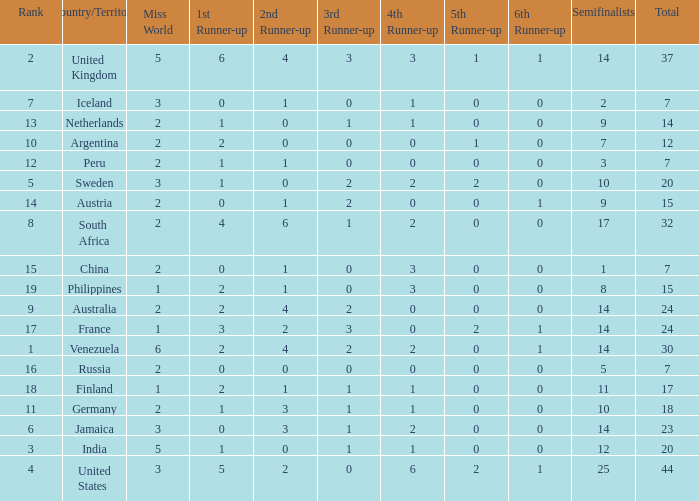What is Iceland's total? 1.0. 